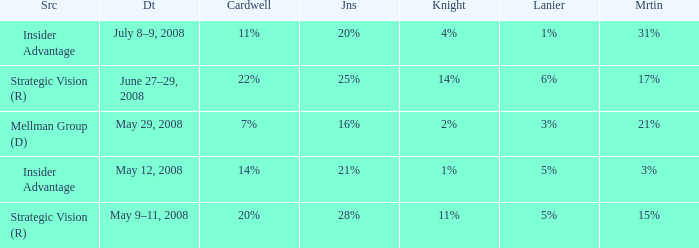What martin is on july 8–9, 2008? 31%. 